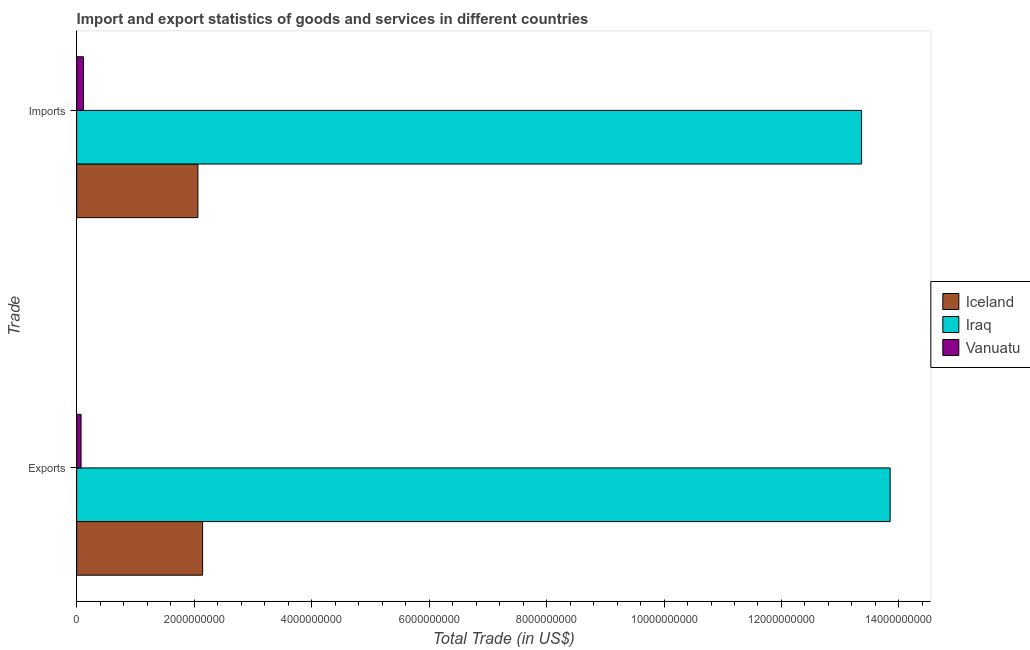How many groups of bars are there?
Provide a succinct answer. 2. How many bars are there on the 1st tick from the bottom?
Keep it short and to the point. 3. What is the label of the 2nd group of bars from the top?
Make the answer very short. Exports. What is the export of goods and services in Vanuatu?
Your answer should be very brief. 7.46e+07. Across all countries, what is the maximum imports of goods and services?
Keep it short and to the point. 1.34e+1. Across all countries, what is the minimum imports of goods and services?
Make the answer very short. 1.16e+08. In which country was the imports of goods and services maximum?
Your answer should be very brief. Iraq. In which country was the imports of goods and services minimum?
Your answer should be very brief. Vanuatu. What is the total imports of goods and services in the graph?
Offer a terse response. 1.55e+1. What is the difference between the imports of goods and services in Vanuatu and that in Iraq?
Give a very brief answer. -1.32e+1. What is the difference between the export of goods and services in Iceland and the imports of goods and services in Iraq?
Keep it short and to the point. -1.12e+1. What is the average export of goods and services per country?
Provide a short and direct response. 5.36e+09. What is the difference between the imports of goods and services and export of goods and services in Vanuatu?
Offer a very short reply. 4.10e+07. What is the ratio of the export of goods and services in Vanuatu to that in Iceland?
Ensure brevity in your answer.  0.03. Is the imports of goods and services in Iceland less than that in Vanuatu?
Offer a very short reply. No. What does the 2nd bar from the top in Imports represents?
Ensure brevity in your answer.  Iraq. What does the 2nd bar from the bottom in Imports represents?
Your answer should be very brief. Iraq. What is the difference between two consecutive major ticks on the X-axis?
Offer a terse response. 2.00e+09. Does the graph contain any zero values?
Your response must be concise. No. How many legend labels are there?
Keep it short and to the point. 3. How are the legend labels stacked?
Provide a succinct answer. Vertical. What is the title of the graph?
Give a very brief answer. Import and export statistics of goods and services in different countries. Does "Haiti" appear as one of the legend labels in the graph?
Your answer should be very brief. No. What is the label or title of the X-axis?
Ensure brevity in your answer.  Total Trade (in US$). What is the label or title of the Y-axis?
Offer a very short reply. Trade. What is the Total Trade (in US$) of Iceland in Exports?
Offer a terse response. 2.14e+09. What is the Total Trade (in US$) in Iraq in Exports?
Ensure brevity in your answer.  1.39e+1. What is the Total Trade (in US$) in Vanuatu in Exports?
Ensure brevity in your answer.  7.46e+07. What is the Total Trade (in US$) of Iceland in Imports?
Give a very brief answer. 2.06e+09. What is the Total Trade (in US$) in Iraq in Imports?
Your response must be concise. 1.34e+1. What is the Total Trade (in US$) in Vanuatu in Imports?
Your answer should be compact. 1.16e+08. Across all Trade, what is the maximum Total Trade (in US$) of Iceland?
Provide a succinct answer. 2.14e+09. Across all Trade, what is the maximum Total Trade (in US$) of Iraq?
Your answer should be very brief. 1.39e+1. Across all Trade, what is the maximum Total Trade (in US$) of Vanuatu?
Provide a short and direct response. 1.16e+08. Across all Trade, what is the minimum Total Trade (in US$) of Iceland?
Give a very brief answer. 2.06e+09. Across all Trade, what is the minimum Total Trade (in US$) of Iraq?
Offer a very short reply. 1.34e+1. Across all Trade, what is the minimum Total Trade (in US$) in Vanuatu?
Offer a very short reply. 7.46e+07. What is the total Total Trade (in US$) of Iceland in the graph?
Make the answer very short. 4.21e+09. What is the total Total Trade (in US$) in Iraq in the graph?
Your answer should be very brief. 2.72e+1. What is the total Total Trade (in US$) of Vanuatu in the graph?
Your answer should be very brief. 1.90e+08. What is the difference between the Total Trade (in US$) of Iceland in Exports and that in Imports?
Your response must be concise. 8.05e+07. What is the difference between the Total Trade (in US$) in Iraq in Exports and that in Imports?
Your answer should be compact. 4.86e+08. What is the difference between the Total Trade (in US$) in Vanuatu in Exports and that in Imports?
Make the answer very short. -4.10e+07. What is the difference between the Total Trade (in US$) in Iceland in Exports and the Total Trade (in US$) in Iraq in Imports?
Provide a succinct answer. -1.12e+1. What is the difference between the Total Trade (in US$) of Iceland in Exports and the Total Trade (in US$) of Vanuatu in Imports?
Give a very brief answer. 2.03e+09. What is the difference between the Total Trade (in US$) in Iraq in Exports and the Total Trade (in US$) in Vanuatu in Imports?
Your answer should be compact. 1.37e+1. What is the average Total Trade (in US$) of Iceland per Trade?
Your answer should be compact. 2.10e+09. What is the average Total Trade (in US$) in Iraq per Trade?
Provide a short and direct response. 1.36e+1. What is the average Total Trade (in US$) of Vanuatu per Trade?
Provide a short and direct response. 9.51e+07. What is the difference between the Total Trade (in US$) in Iceland and Total Trade (in US$) in Iraq in Exports?
Offer a terse response. -1.17e+1. What is the difference between the Total Trade (in US$) in Iceland and Total Trade (in US$) in Vanuatu in Exports?
Your answer should be very brief. 2.07e+09. What is the difference between the Total Trade (in US$) in Iraq and Total Trade (in US$) in Vanuatu in Exports?
Offer a terse response. 1.38e+1. What is the difference between the Total Trade (in US$) in Iceland and Total Trade (in US$) in Iraq in Imports?
Your response must be concise. -1.13e+1. What is the difference between the Total Trade (in US$) in Iceland and Total Trade (in US$) in Vanuatu in Imports?
Make the answer very short. 1.95e+09. What is the difference between the Total Trade (in US$) of Iraq and Total Trade (in US$) of Vanuatu in Imports?
Your answer should be compact. 1.32e+1. What is the ratio of the Total Trade (in US$) of Iceland in Exports to that in Imports?
Provide a short and direct response. 1.04. What is the ratio of the Total Trade (in US$) of Iraq in Exports to that in Imports?
Give a very brief answer. 1.04. What is the ratio of the Total Trade (in US$) in Vanuatu in Exports to that in Imports?
Your answer should be very brief. 0.65. What is the difference between the highest and the second highest Total Trade (in US$) in Iceland?
Give a very brief answer. 8.05e+07. What is the difference between the highest and the second highest Total Trade (in US$) of Iraq?
Provide a short and direct response. 4.86e+08. What is the difference between the highest and the second highest Total Trade (in US$) in Vanuatu?
Make the answer very short. 4.10e+07. What is the difference between the highest and the lowest Total Trade (in US$) of Iceland?
Keep it short and to the point. 8.05e+07. What is the difference between the highest and the lowest Total Trade (in US$) in Iraq?
Offer a terse response. 4.86e+08. What is the difference between the highest and the lowest Total Trade (in US$) in Vanuatu?
Your answer should be very brief. 4.10e+07. 